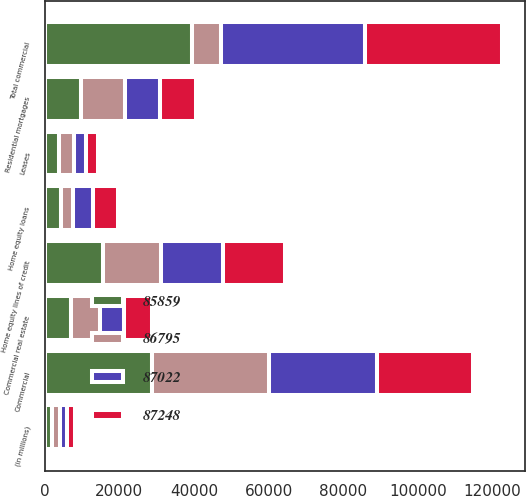<chart> <loc_0><loc_0><loc_500><loc_500><stacked_bar_chart><ecel><fcel>(in millions)<fcel>Commercial<fcel>Commercial real estate<fcel>Leases<fcel>Total commercial<fcel>Residential mortgages<fcel>Home equity loans<fcel>Home equity lines of credit<nl><fcel>86795<fcel>2014<fcel>31431<fcel>7809<fcel>3986<fcel>7809<fcel>11832<fcel>3424<fcel>15423<nl><fcel>85859<fcel>2013<fcel>28667<fcel>6948<fcel>3780<fcel>39395<fcel>9726<fcel>4301<fcel>15667<nl><fcel>87022<fcel>2012<fcel>28856<fcel>6459<fcel>3415<fcel>38730<fcel>9323<fcel>5106<fcel>16672<nl><fcel>87248<fcel>2011<fcel>25770<fcel>7602<fcel>3164<fcel>36536<fcel>9719<fcel>6766<fcel>16666<nl></chart> 